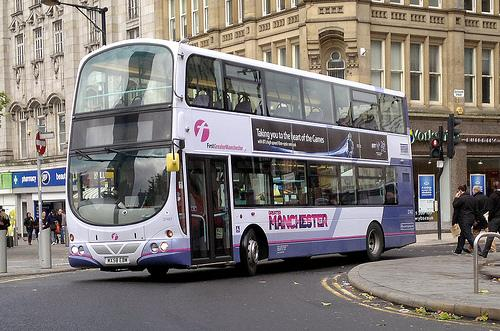Briefly describe the scene, focusing on the people in the image. A lady is walking while holding a phone, and a woman is talking on her cellphone near a large bus and various signs. Provide a brief description of the signs and their colors shown in the image. There are multiple signs: a black X sign, a red sign, a blue sign with white words, a red and white symbol, and a pink logo. Describe the scene in terms of objects and their interactions. A woman is walking near a bus with yellow mirror, several signs are located around, and large buildings with glass windows are in the background. Discuss the different objects shown in the image and their locations. The image includes objects like signs, a lady, a bus with green object, a tan building, a pink logo, and glass windows at various coordinates. Describe the layout and details of the large bus. The bus features multiple glass windows and a yellow mirror, along with an advertisement, green object, and red and white symbol. Mention the prominent colors and features in the image. Prominent colors are red, yellow, blue, green, pink, and tan; features include a large double-decker bus, a walking woman, and signs. Provide a description of the most prominent object in the image. A large double-decker bus with yellow mirror and green object, displaying a partial advertisment with white words, and multiple glass windows. Summarize the scene depicted in the image. The image shows a large tan building, a woman talking on a cell phone, several signs, and a large bus with many glass windows. Explain the elements related to the woman talking on a cellphone. A woman is walking and talking on a cellphone, holding a phone, and she is positioned near a large bus with several glass windows. Depict the situation within the context of a street scene. On a busy street, a woman walks by a large bus and various signs, with tall buildings and glass windows in the backdrop. 